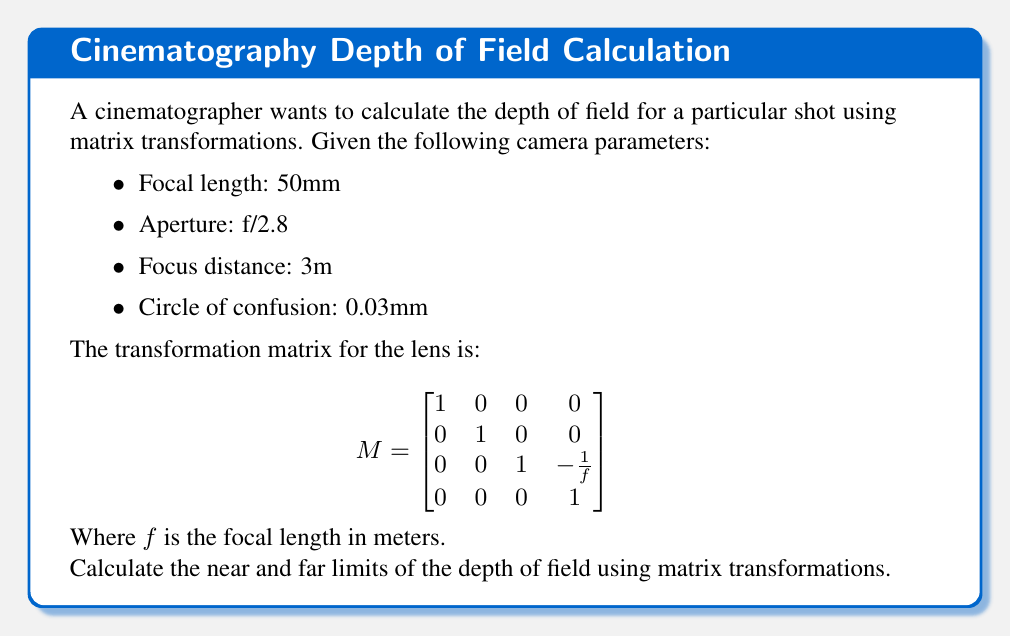Teach me how to tackle this problem. To calculate the depth of field using matrix transformations, we'll follow these steps:

1) First, convert the focal length to meters:
   $f = 50mm = 0.05m$

2) Calculate the f-number:
   $N = 2.8$

3) Convert the circle of confusion to meters:
   $c = 0.03mm = 0.00003m$

4) The transformation matrix M becomes:

   $$
   M = \begin{bmatrix}
   1 & 0 & 0 & 0 \\
   0 & 1 & 0 & 0 \\
   0 & 0 & 1 & -20 \\
   0 & 0 & 0 & 1
   \end{bmatrix}
   $$

5) The hyperfocal distance H is given by:
   $H = \frac{f^2}{Nc} + f = \frac{0.05^2}{2.8 \cdot 0.00003} + 0.05 = 29.76m$

6) To find the near limit $D_n$ and far limit $D_f$, we use:
   $D_n = \frac{sH}{H+s-f}$
   $D_f = \frac{sH}{H-s+f}$

   Where $s$ is the focus distance (3m).

7) Calculating:
   $D_n = \frac{3 \cdot 29.76}{29.76 + 3 - 0.05} = 2.71m$
   $D_f = \frac{3 \cdot 29.76}{29.76 - 3 + 0.05} = 3.35m$

8) To express this as a matrix transformation, we can use:

   $$
   \begin{bmatrix}
   D_n \\
   D_f \\
   1
   \end{bmatrix} = 
   \begin{bmatrix}
   \frac{H}{H+s-f} & 0 & 0 \\
   0 & \frac{H}{H-s+f} & 0 \\
   0 & 0 & 1
   \end{bmatrix}
   \begin{bmatrix}
   s \\
   s \\
   1
   \end{bmatrix}
   $$

   Which gives us:

   $$
   \begin{bmatrix}
   D_n \\
   D_f \\
   1
   \end{bmatrix} = 
   \begin{bmatrix}
   0.9033 & 0 & 0 \\
   0 & 1.1167 & 0 \\
   0 & 0 & 1
   \end{bmatrix}
   \begin{bmatrix}
   3 \\
   3 \\
   1
   \end{bmatrix} =
   \begin{bmatrix}
   2.71 \\
   3.35 \\
   1
   \end{bmatrix}
   $$

This matrix transformation represents the calculation of the near and far limits of the depth of field.
Answer: The near limit of the depth of field is 2.71m, and the far limit is 3.35m. 